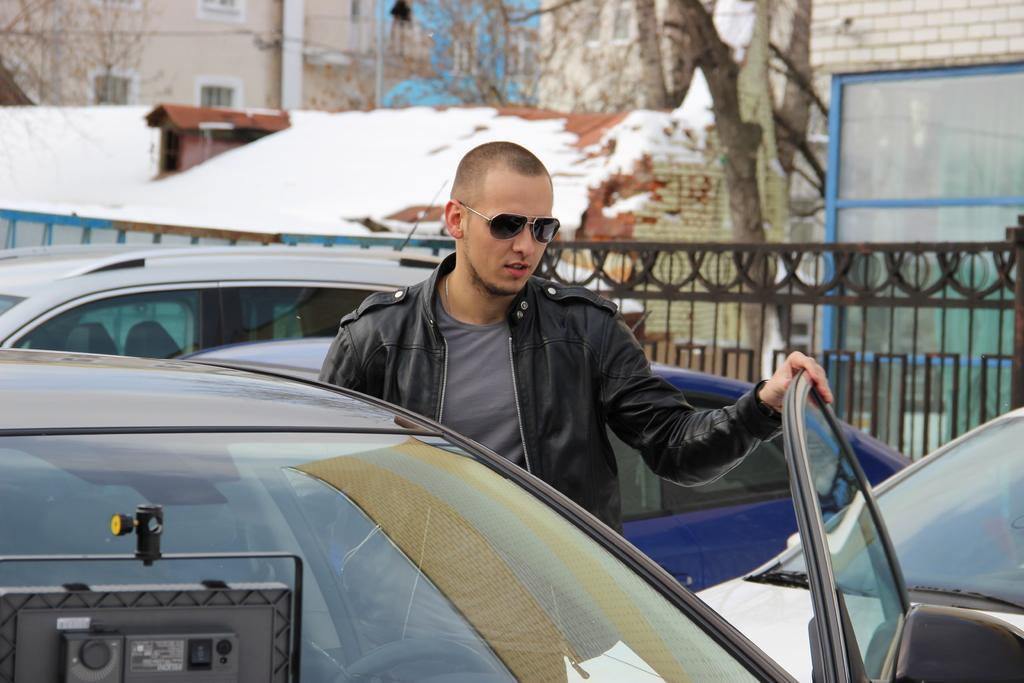How would you summarize this image in a sentence or two? This is the man standing. He wore a jacket, T-shirt and goggles. These are the cars, which are parked. This looks like an iron gate. I can see the buildings with windows. This looks like a tree trunk. 